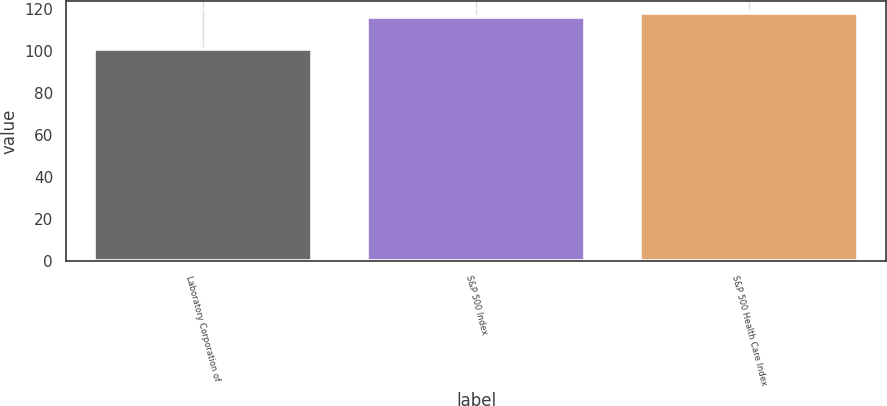<chart> <loc_0><loc_0><loc_500><loc_500><bar_chart><fcel>Laboratory Corporation of<fcel>S&P 500 Index<fcel>S&P 500 Health Care Index<nl><fcel>100.76<fcel>116<fcel>117.89<nl></chart> 